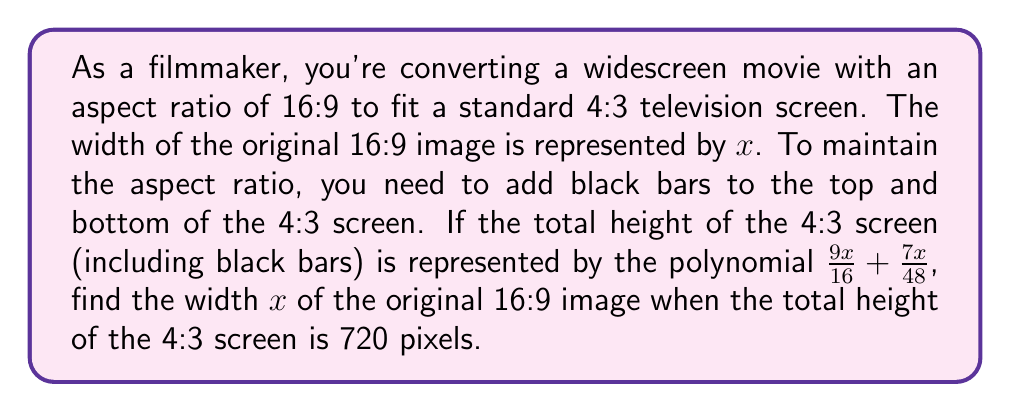Can you solve this math problem? Let's approach this step-by-step:

1) We're given that the total height of the 4:3 screen is represented by the polynomial $\frac{9x}{16} + \frac{7x}{48}$, where $x$ is the width of the original 16:9 image.

2) We're also told that this total height is 720 pixels. So we can set up the equation:

   $$\frac{9x}{16} + \frac{7x}{48} = 720$$

3) To solve this, let's first find a common denominator for the left side of the equation:
   
   $$\frac{27x}{48} + \frac{7x}{48} = 720$$

4) Now we can combine like terms:

   $$\frac{34x}{48} = 720$$

5) Multiply both sides by 48:

   $$34x = 720 * 48$$

6) Simplify the right side:

   $$34x = 34560$$

7) Finally, divide both sides by 34:

   $$x = \frac{34560}{34} = 1016.47...$$

8) Since we're dealing with pixels, we should round to the nearest whole number.
Answer: The width $x$ of the original 16:9 image is 1016 pixels. 